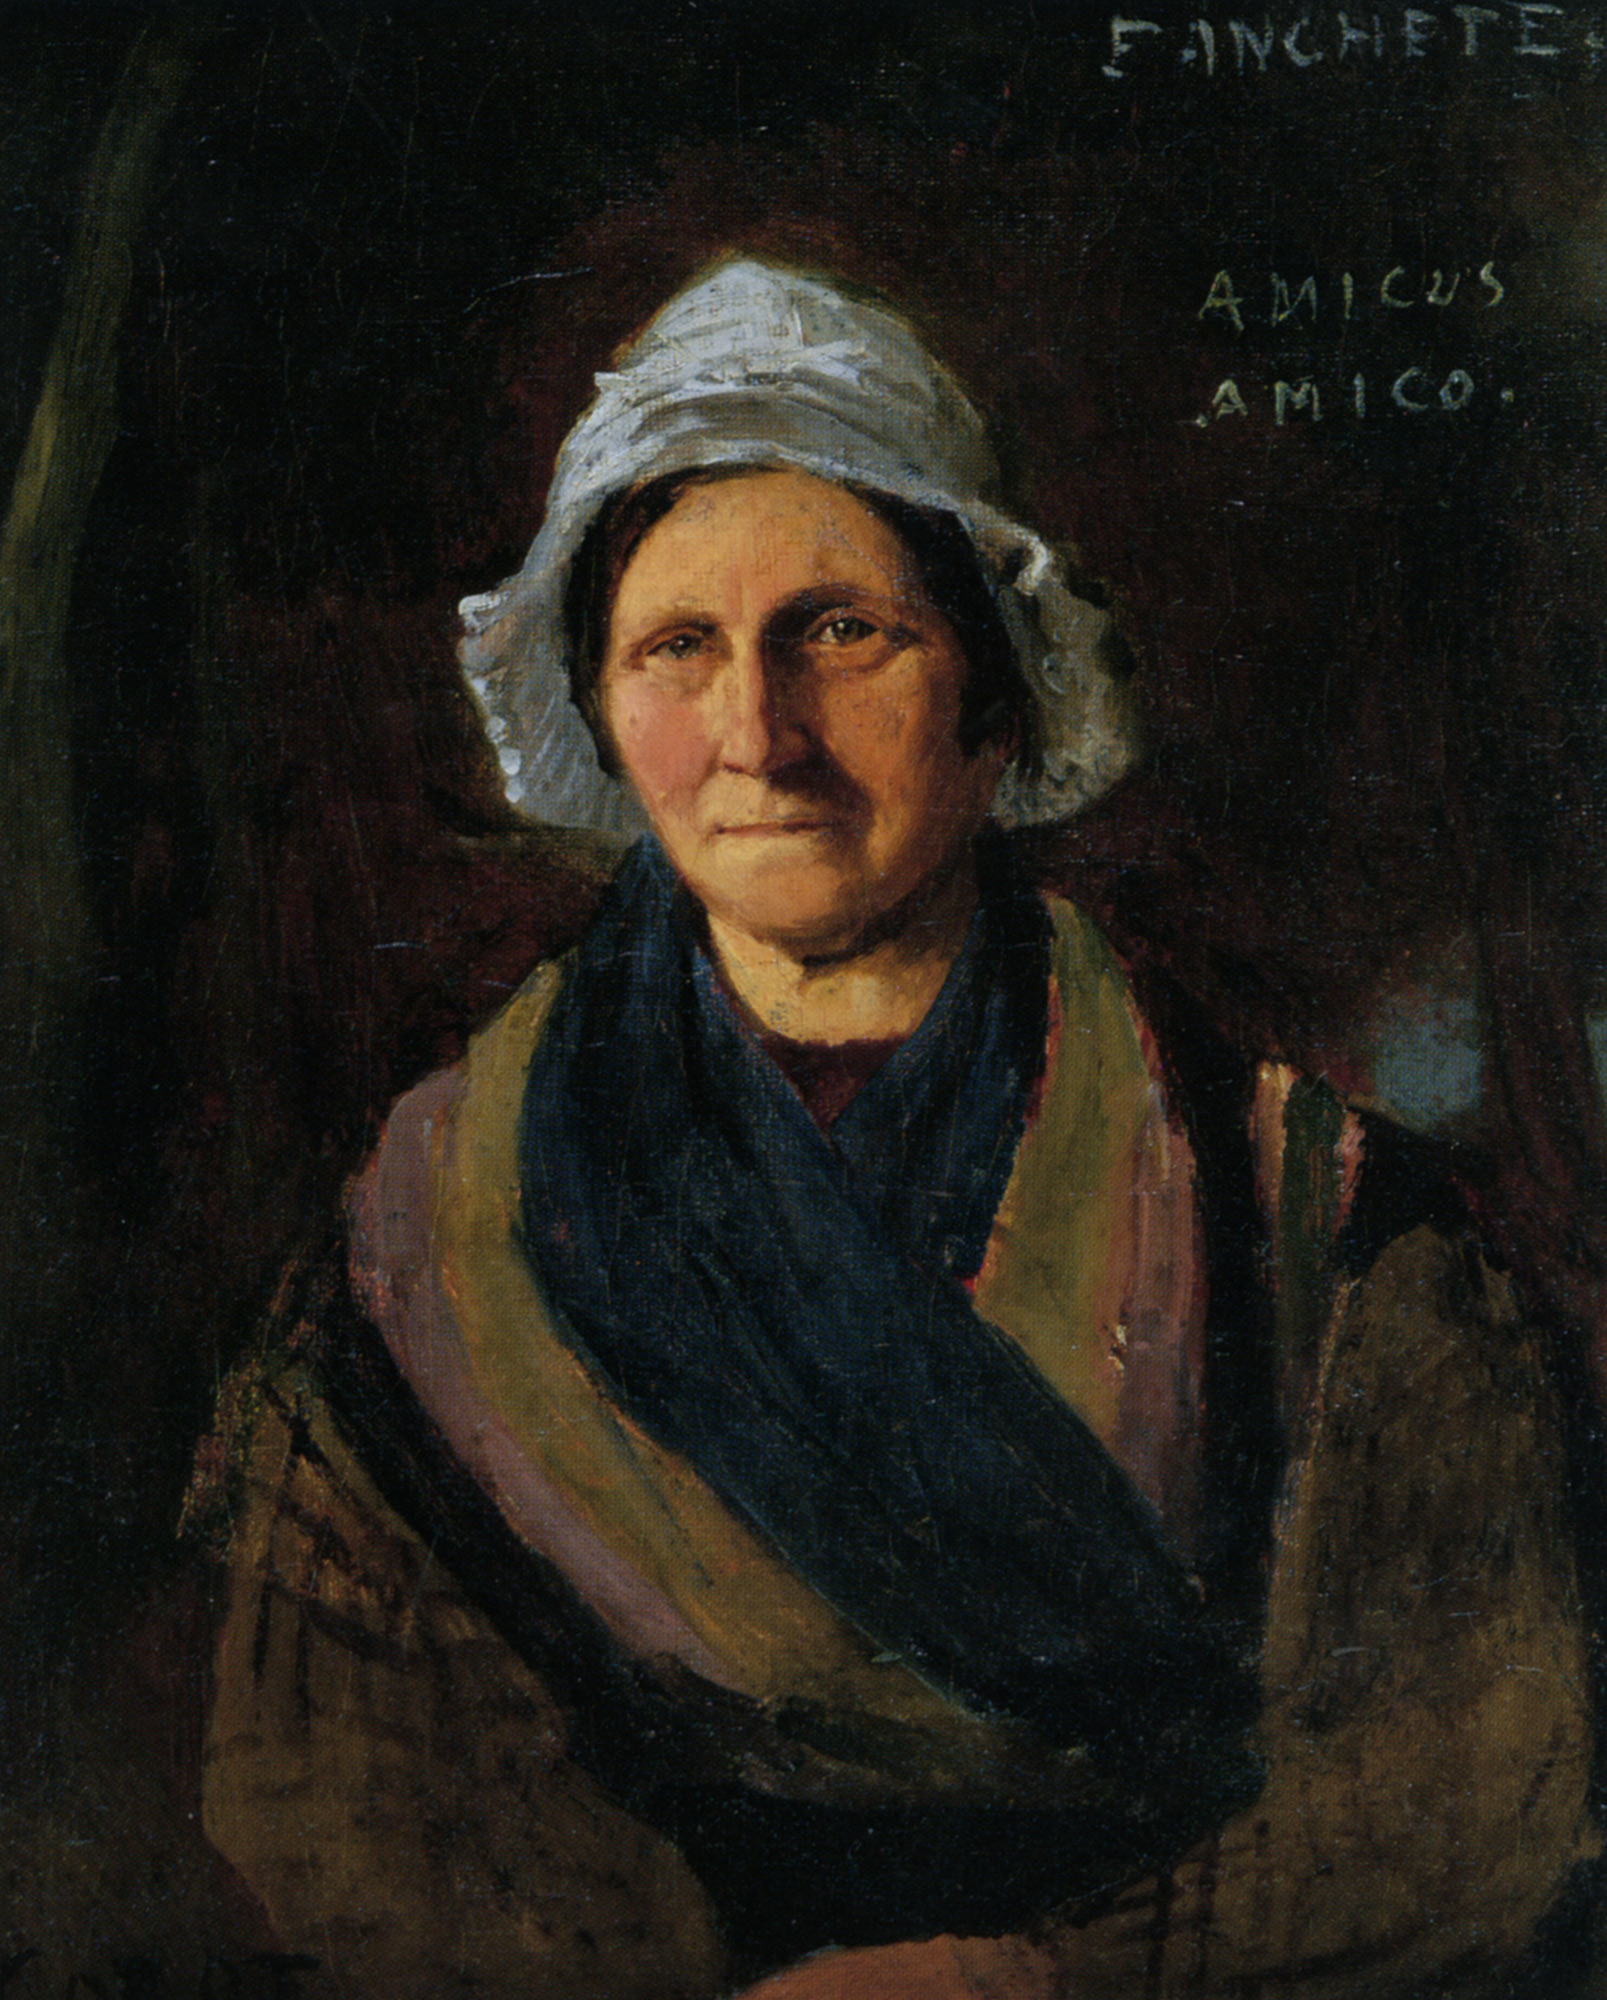How might this painting be significant in a historical sense? Historically, this painting might be significant as a representation of women's roles and lives during the time it was created. It provides insight into the fashion, demeanor, and possibly the social status of women in that era. The detailed and realistic depiction suggests an emphasis on portraying individuals with depth and character, offering a glimpse into the personal lives and emotional experiences of people from history. The inscription 'AMICUS AMICO' could indicate connections and friendships during that period, adding further layers to our understanding of the societal context in which this piece was created.  If this painting were part of a larger collection, what themes might the collection explore? If this painting were part of a larger collection, the themes might explore the resilience and everyday lives of women throughout history. The collection could feature portraits of women from various socio-economic backgrounds, depicting their struggles, joys, and contributions to their communities. It might also delve into themes of friendship, as hinted by 'AMICUS AMICO,' and how social connections have shaped personal and collective histories. Additionally, the collection could highlight the evolution of artistic techniques in portraiture, showcasing the progression from early rudimentary depictions to highly detailed and realistic representations. 